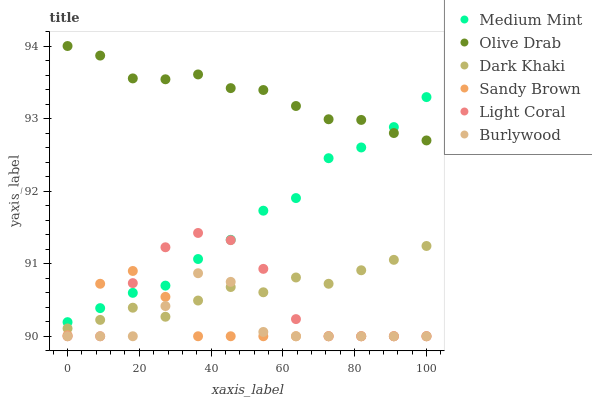Does Burlywood have the minimum area under the curve?
Answer yes or no. Yes. Does Olive Drab have the maximum area under the curve?
Answer yes or no. Yes. Does Light Coral have the minimum area under the curve?
Answer yes or no. No. Does Light Coral have the maximum area under the curve?
Answer yes or no. No. Is Olive Drab the smoothest?
Answer yes or no. Yes. Is Light Coral the roughest?
Answer yes or no. Yes. Is Burlywood the smoothest?
Answer yes or no. No. Is Burlywood the roughest?
Answer yes or no. No. Does Light Coral have the lowest value?
Answer yes or no. Yes. Does Dark Khaki have the lowest value?
Answer yes or no. No. Does Olive Drab have the highest value?
Answer yes or no. Yes. Does Light Coral have the highest value?
Answer yes or no. No. Is Burlywood less than Medium Mint?
Answer yes or no. Yes. Is Olive Drab greater than Burlywood?
Answer yes or no. Yes. Does Light Coral intersect Medium Mint?
Answer yes or no. Yes. Is Light Coral less than Medium Mint?
Answer yes or no. No. Is Light Coral greater than Medium Mint?
Answer yes or no. No. Does Burlywood intersect Medium Mint?
Answer yes or no. No. 